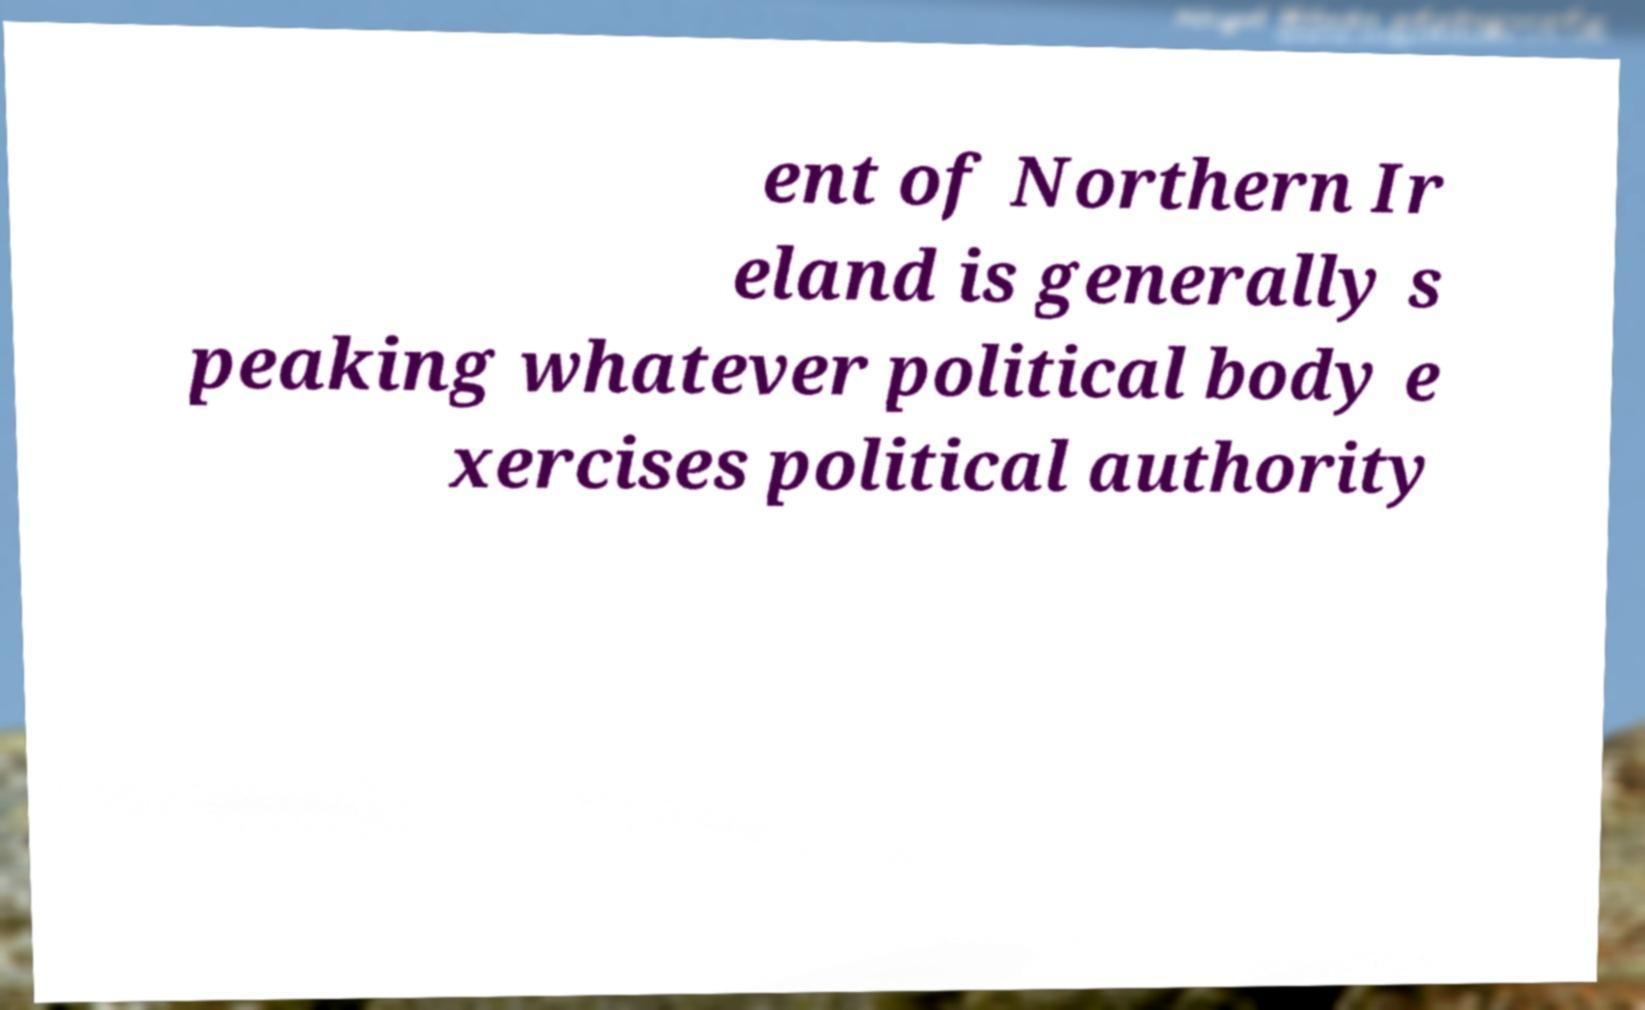Could you assist in decoding the text presented in this image and type it out clearly? ent of Northern Ir eland is generally s peaking whatever political body e xercises political authority 